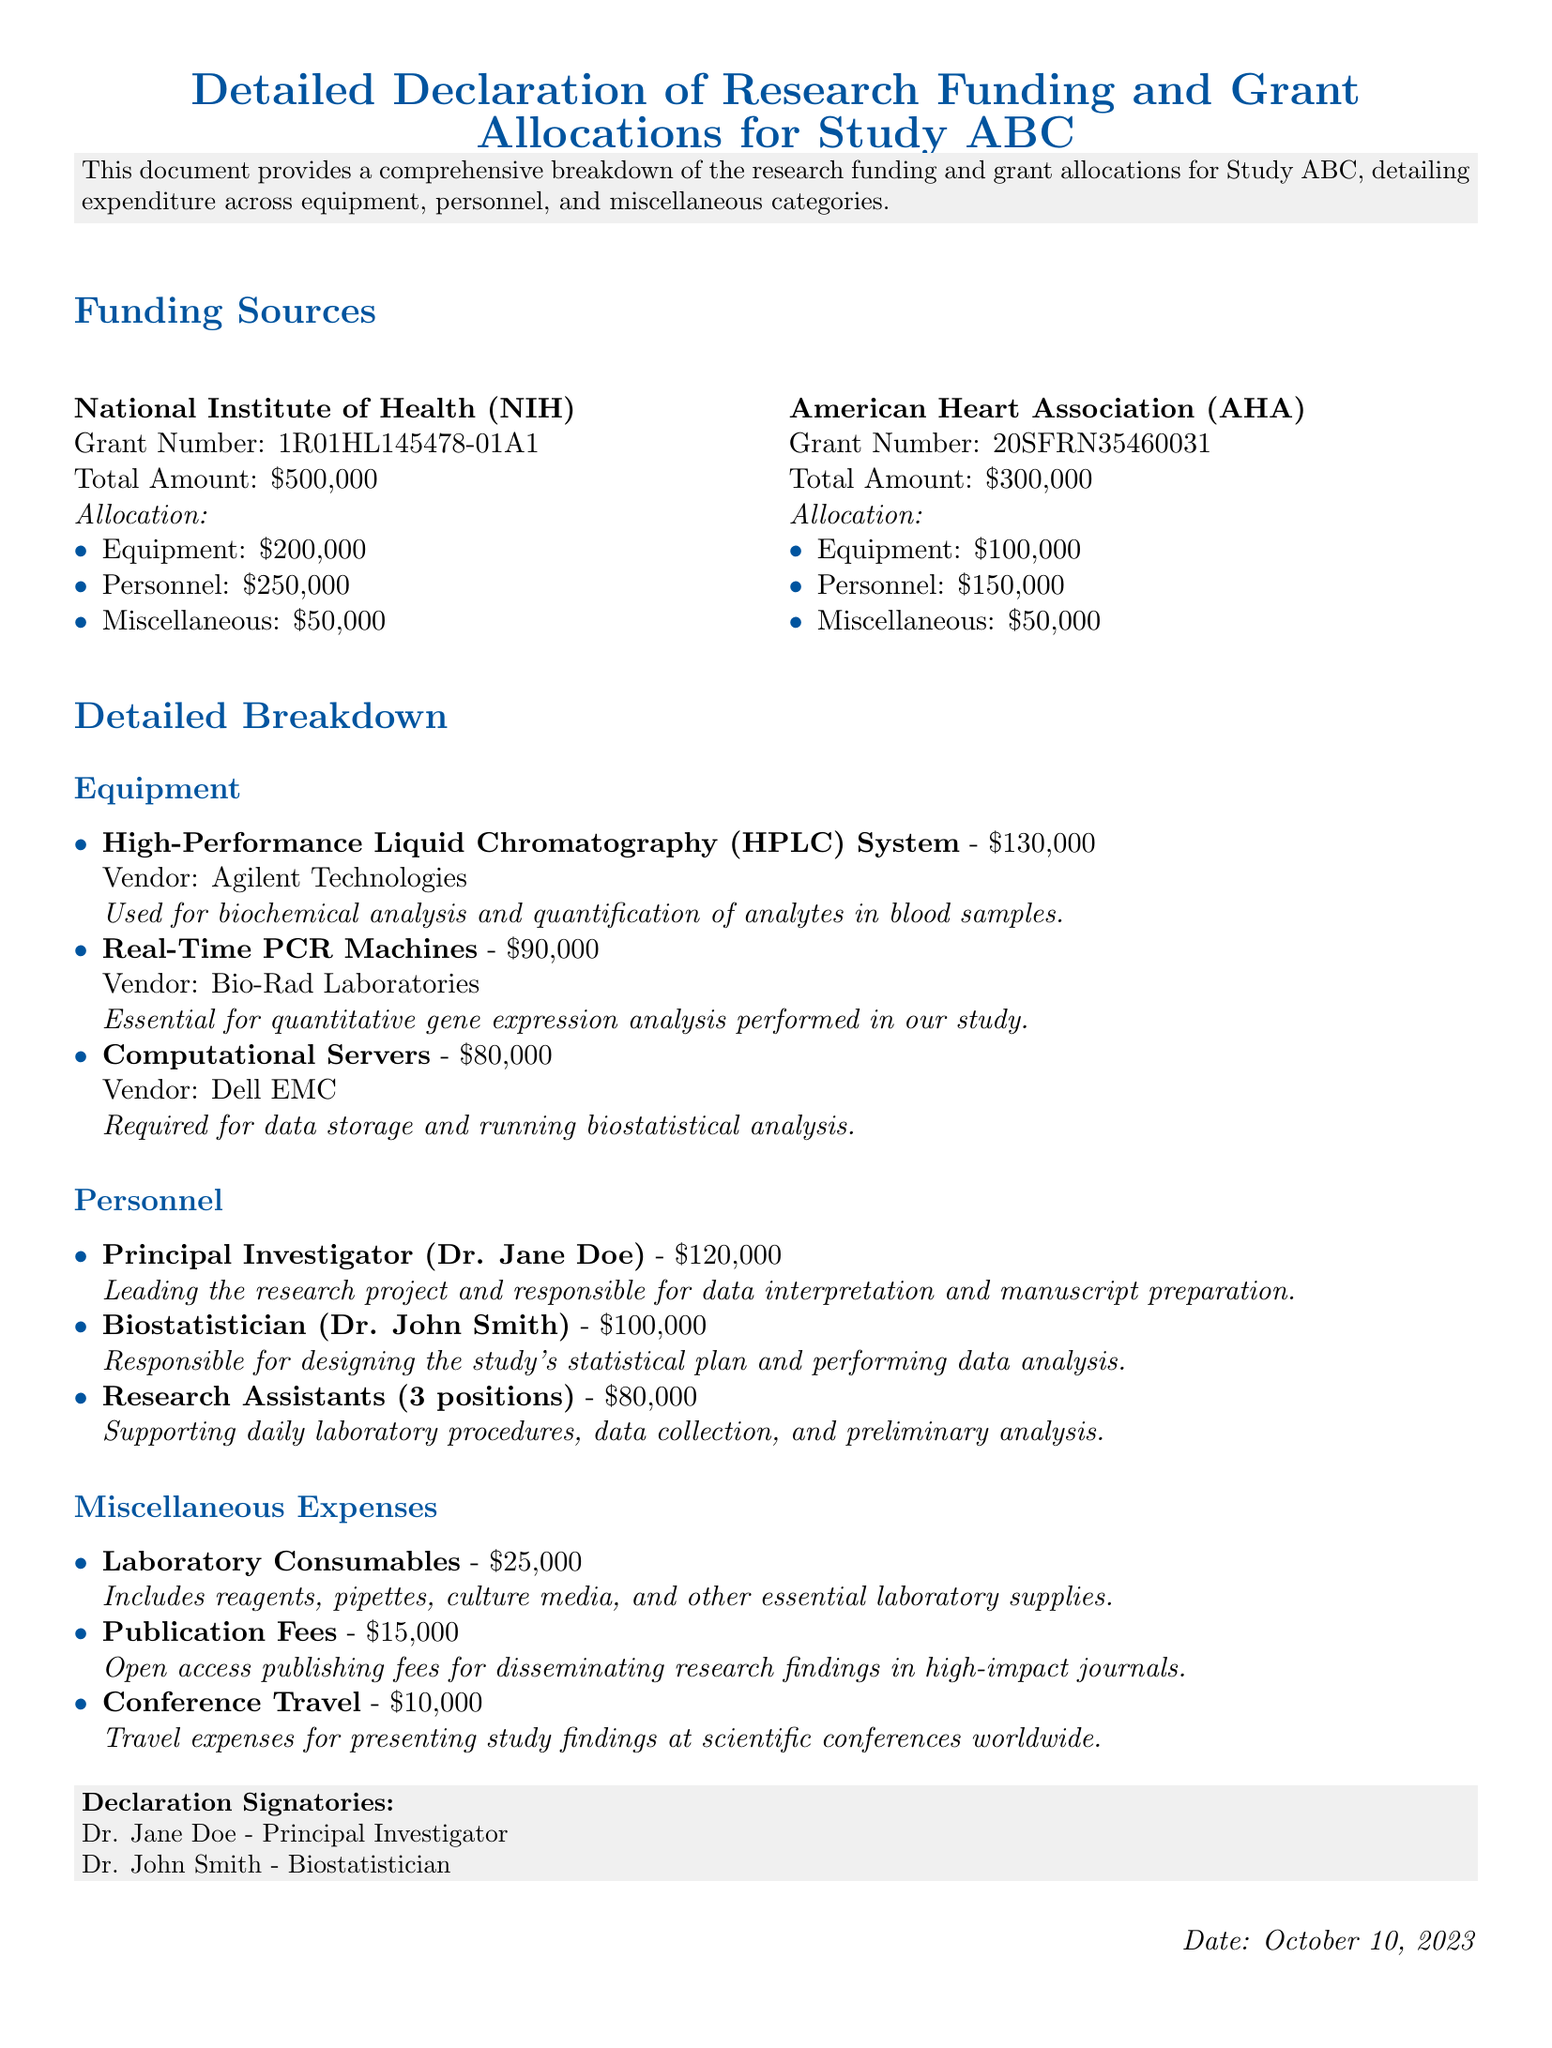What is the total amount of funding from the NIH? The total amount of funding from the NIH is stated as $500,000 in the document.
Answer: $500,000 How much is allocated for personnel in the AHA grant? The document specifies that the allocation for personnel in the AHA grant is $150,000.
Answer: $150,000 What is the name of the Principal Investigator? The document lists Dr. Jane Doe as the Principal Investigator for the study.
Answer: Dr. Jane Doe What is the total amount allocated for equipment across both funding sources? The equipment allocations are $200,000 from NIH and $100,000 from AHA, totaling $300,000.
Answer: $300,000 How many research assistants are mentioned in the personnel section? The document indicates there are three research assistants listed in the personnel section.
Answer: 3 What is the total amount allocated for miscellaneous expenses? The total amount for miscellaneous expenses is the sum of $50,000 from NIH and $50,000 from AHA, equalling $100,000.
Answer: $100,000 Which vendor provided the HPLC system? The document states that Agilent Technologies is the vendor for the HPLC system.
Answer: Agilent Technologies What is the purpose of the Real-Time PCR Machines? The document mentions that the machine is essential for quantitative gene expression analysis performed in the study.
Answer: Quantitative gene expression analysis When was this document signed? The date of the document is mentioned as October 10, 2023.
Answer: October 10, 2023 